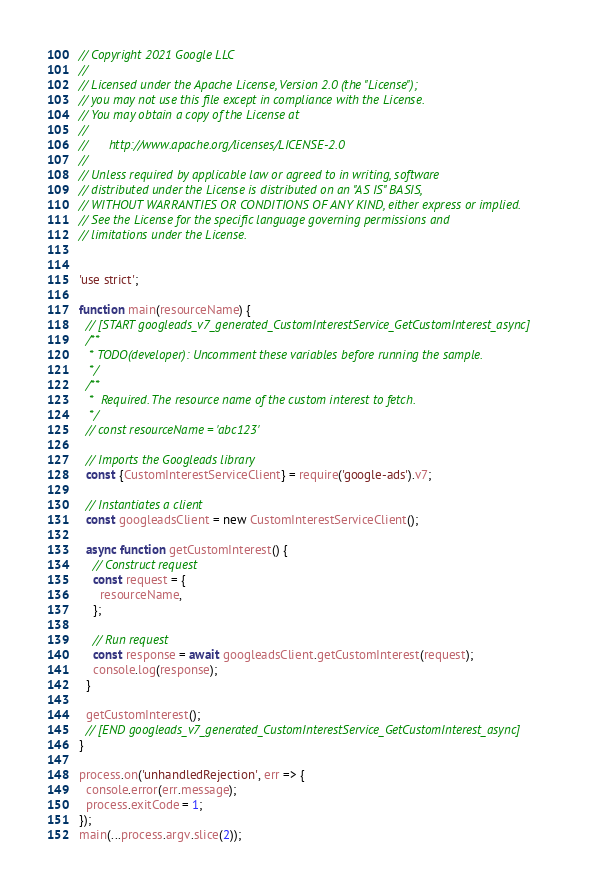<code> <loc_0><loc_0><loc_500><loc_500><_JavaScript_>// Copyright 2021 Google LLC
//
// Licensed under the Apache License, Version 2.0 (the "License");
// you may not use this file except in compliance with the License.
// You may obtain a copy of the License at
//
//      http://www.apache.org/licenses/LICENSE-2.0
//
// Unless required by applicable law or agreed to in writing, software
// distributed under the License is distributed on an "AS IS" BASIS,
// WITHOUT WARRANTIES OR CONDITIONS OF ANY KIND, either express or implied.
// See the License for the specific language governing permissions and
// limitations under the License.


'use strict';

function main(resourceName) {
  // [START googleads_v7_generated_CustomInterestService_GetCustomInterest_async]
  /**
   * TODO(developer): Uncomment these variables before running the sample.
   */
  /**
   *  Required. The resource name of the custom interest to fetch.
   */
  // const resourceName = 'abc123'

  // Imports the Googleads library
  const {CustomInterestServiceClient} = require('google-ads').v7;

  // Instantiates a client
  const googleadsClient = new CustomInterestServiceClient();

  async function getCustomInterest() {
    // Construct request
    const request = {
      resourceName,
    };

    // Run request
    const response = await googleadsClient.getCustomInterest(request);
    console.log(response);
  }

  getCustomInterest();
  // [END googleads_v7_generated_CustomInterestService_GetCustomInterest_async]
}

process.on('unhandledRejection', err => {
  console.error(err.message);
  process.exitCode = 1;
});
main(...process.argv.slice(2));
</code> 